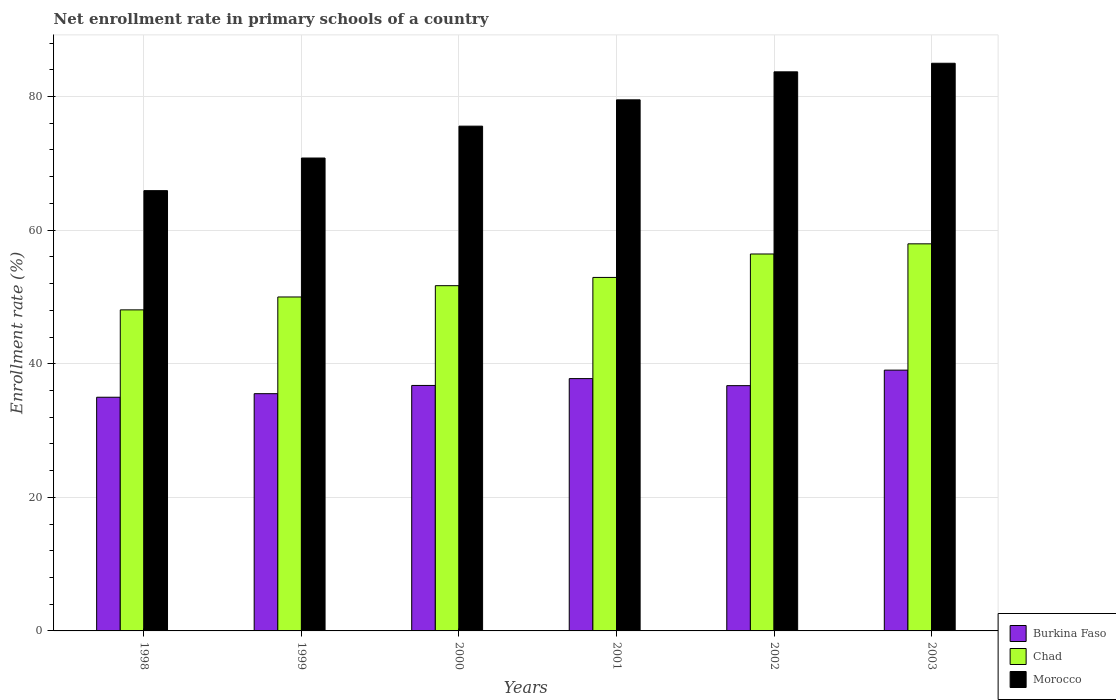Are the number of bars on each tick of the X-axis equal?
Provide a short and direct response. Yes. How many bars are there on the 6th tick from the right?
Offer a terse response. 3. What is the label of the 3rd group of bars from the left?
Provide a short and direct response. 2000. In how many cases, is the number of bars for a given year not equal to the number of legend labels?
Make the answer very short. 0. What is the enrollment rate in primary schools in Burkina Faso in 2000?
Ensure brevity in your answer.  36.75. Across all years, what is the maximum enrollment rate in primary schools in Burkina Faso?
Offer a very short reply. 39.04. Across all years, what is the minimum enrollment rate in primary schools in Chad?
Offer a very short reply. 48.06. In which year was the enrollment rate in primary schools in Chad maximum?
Your answer should be very brief. 2003. In which year was the enrollment rate in primary schools in Morocco minimum?
Offer a terse response. 1998. What is the total enrollment rate in primary schools in Burkina Faso in the graph?
Ensure brevity in your answer.  220.78. What is the difference between the enrollment rate in primary schools in Chad in 1999 and that in 2002?
Your answer should be compact. -6.43. What is the difference between the enrollment rate in primary schools in Burkina Faso in 2000 and the enrollment rate in primary schools in Chad in 2003?
Offer a terse response. -21.2. What is the average enrollment rate in primary schools in Chad per year?
Offer a terse response. 52.84. In the year 1998, what is the difference between the enrollment rate in primary schools in Burkina Faso and enrollment rate in primary schools in Chad?
Your response must be concise. -13.08. In how many years, is the enrollment rate in primary schools in Burkina Faso greater than 84 %?
Offer a terse response. 0. What is the ratio of the enrollment rate in primary schools in Chad in 2001 to that in 2003?
Your answer should be very brief. 0.91. Is the enrollment rate in primary schools in Chad in 1998 less than that in 1999?
Offer a terse response. Yes. Is the difference between the enrollment rate in primary schools in Burkina Faso in 2001 and 2002 greater than the difference between the enrollment rate in primary schools in Chad in 2001 and 2002?
Keep it short and to the point. Yes. What is the difference between the highest and the second highest enrollment rate in primary schools in Burkina Faso?
Keep it short and to the point. 1.27. What is the difference between the highest and the lowest enrollment rate in primary schools in Chad?
Ensure brevity in your answer.  9.88. In how many years, is the enrollment rate in primary schools in Morocco greater than the average enrollment rate in primary schools in Morocco taken over all years?
Offer a very short reply. 3. Is the sum of the enrollment rate in primary schools in Chad in 2001 and 2003 greater than the maximum enrollment rate in primary schools in Morocco across all years?
Your response must be concise. Yes. What does the 3rd bar from the left in 2003 represents?
Offer a terse response. Morocco. What does the 1st bar from the right in 1998 represents?
Keep it short and to the point. Morocco. Is it the case that in every year, the sum of the enrollment rate in primary schools in Burkina Faso and enrollment rate in primary schools in Chad is greater than the enrollment rate in primary schools in Morocco?
Keep it short and to the point. Yes. How many bars are there?
Your answer should be very brief. 18. Are all the bars in the graph horizontal?
Offer a terse response. No. How many years are there in the graph?
Your answer should be very brief. 6. What is the difference between two consecutive major ticks on the Y-axis?
Offer a very short reply. 20. Does the graph contain any zero values?
Offer a very short reply. No. How are the legend labels stacked?
Your answer should be compact. Vertical. What is the title of the graph?
Provide a succinct answer. Net enrollment rate in primary schools of a country. Does "Ecuador" appear as one of the legend labels in the graph?
Your response must be concise. No. What is the label or title of the X-axis?
Your answer should be very brief. Years. What is the label or title of the Y-axis?
Your response must be concise. Enrollment rate (%). What is the Enrollment rate (%) in Burkina Faso in 1998?
Your answer should be very brief. 34.98. What is the Enrollment rate (%) of Chad in 1998?
Provide a succinct answer. 48.06. What is the Enrollment rate (%) in Morocco in 1998?
Provide a short and direct response. 65.91. What is the Enrollment rate (%) of Burkina Faso in 1999?
Ensure brevity in your answer.  35.52. What is the Enrollment rate (%) of Chad in 1999?
Offer a very short reply. 49.99. What is the Enrollment rate (%) in Morocco in 1999?
Your answer should be compact. 70.79. What is the Enrollment rate (%) of Burkina Faso in 2000?
Your response must be concise. 36.75. What is the Enrollment rate (%) of Chad in 2000?
Make the answer very short. 51.68. What is the Enrollment rate (%) in Morocco in 2000?
Your answer should be very brief. 75.57. What is the Enrollment rate (%) in Burkina Faso in 2001?
Provide a short and direct response. 37.77. What is the Enrollment rate (%) in Chad in 2001?
Your response must be concise. 52.92. What is the Enrollment rate (%) in Morocco in 2001?
Your response must be concise. 79.5. What is the Enrollment rate (%) in Burkina Faso in 2002?
Your answer should be compact. 36.72. What is the Enrollment rate (%) of Chad in 2002?
Make the answer very short. 56.43. What is the Enrollment rate (%) of Morocco in 2002?
Ensure brevity in your answer.  83.7. What is the Enrollment rate (%) in Burkina Faso in 2003?
Your answer should be compact. 39.04. What is the Enrollment rate (%) in Chad in 2003?
Provide a short and direct response. 57.95. What is the Enrollment rate (%) in Morocco in 2003?
Provide a short and direct response. 84.98. Across all years, what is the maximum Enrollment rate (%) of Burkina Faso?
Offer a terse response. 39.04. Across all years, what is the maximum Enrollment rate (%) of Chad?
Provide a short and direct response. 57.95. Across all years, what is the maximum Enrollment rate (%) in Morocco?
Make the answer very short. 84.98. Across all years, what is the minimum Enrollment rate (%) of Burkina Faso?
Ensure brevity in your answer.  34.98. Across all years, what is the minimum Enrollment rate (%) in Chad?
Offer a very short reply. 48.06. Across all years, what is the minimum Enrollment rate (%) in Morocco?
Offer a terse response. 65.91. What is the total Enrollment rate (%) of Burkina Faso in the graph?
Offer a very short reply. 220.78. What is the total Enrollment rate (%) of Chad in the graph?
Make the answer very short. 317.03. What is the total Enrollment rate (%) of Morocco in the graph?
Ensure brevity in your answer.  460.45. What is the difference between the Enrollment rate (%) of Burkina Faso in 1998 and that in 1999?
Your answer should be very brief. -0.53. What is the difference between the Enrollment rate (%) in Chad in 1998 and that in 1999?
Keep it short and to the point. -1.93. What is the difference between the Enrollment rate (%) in Morocco in 1998 and that in 1999?
Ensure brevity in your answer.  -4.88. What is the difference between the Enrollment rate (%) in Burkina Faso in 1998 and that in 2000?
Your response must be concise. -1.77. What is the difference between the Enrollment rate (%) in Chad in 1998 and that in 2000?
Make the answer very short. -3.62. What is the difference between the Enrollment rate (%) in Morocco in 1998 and that in 2000?
Provide a short and direct response. -9.66. What is the difference between the Enrollment rate (%) in Burkina Faso in 1998 and that in 2001?
Ensure brevity in your answer.  -2.79. What is the difference between the Enrollment rate (%) in Chad in 1998 and that in 2001?
Give a very brief answer. -4.86. What is the difference between the Enrollment rate (%) of Morocco in 1998 and that in 2001?
Provide a short and direct response. -13.6. What is the difference between the Enrollment rate (%) of Burkina Faso in 1998 and that in 2002?
Ensure brevity in your answer.  -1.74. What is the difference between the Enrollment rate (%) in Chad in 1998 and that in 2002?
Provide a short and direct response. -8.36. What is the difference between the Enrollment rate (%) in Morocco in 1998 and that in 2002?
Offer a very short reply. -17.79. What is the difference between the Enrollment rate (%) of Burkina Faso in 1998 and that in 2003?
Provide a short and direct response. -4.06. What is the difference between the Enrollment rate (%) of Chad in 1998 and that in 2003?
Your answer should be very brief. -9.88. What is the difference between the Enrollment rate (%) of Morocco in 1998 and that in 2003?
Provide a short and direct response. -19.07. What is the difference between the Enrollment rate (%) of Burkina Faso in 1999 and that in 2000?
Give a very brief answer. -1.23. What is the difference between the Enrollment rate (%) in Chad in 1999 and that in 2000?
Your response must be concise. -1.69. What is the difference between the Enrollment rate (%) of Morocco in 1999 and that in 2000?
Provide a succinct answer. -4.77. What is the difference between the Enrollment rate (%) of Burkina Faso in 1999 and that in 2001?
Your answer should be very brief. -2.26. What is the difference between the Enrollment rate (%) in Chad in 1999 and that in 2001?
Your response must be concise. -2.93. What is the difference between the Enrollment rate (%) in Morocco in 1999 and that in 2001?
Your response must be concise. -8.71. What is the difference between the Enrollment rate (%) of Burkina Faso in 1999 and that in 2002?
Provide a short and direct response. -1.2. What is the difference between the Enrollment rate (%) in Chad in 1999 and that in 2002?
Your answer should be compact. -6.43. What is the difference between the Enrollment rate (%) of Morocco in 1999 and that in 2002?
Offer a terse response. -12.9. What is the difference between the Enrollment rate (%) of Burkina Faso in 1999 and that in 2003?
Give a very brief answer. -3.52. What is the difference between the Enrollment rate (%) in Chad in 1999 and that in 2003?
Your answer should be compact. -7.95. What is the difference between the Enrollment rate (%) of Morocco in 1999 and that in 2003?
Make the answer very short. -14.19. What is the difference between the Enrollment rate (%) in Burkina Faso in 2000 and that in 2001?
Keep it short and to the point. -1.02. What is the difference between the Enrollment rate (%) in Chad in 2000 and that in 2001?
Provide a succinct answer. -1.24. What is the difference between the Enrollment rate (%) of Morocco in 2000 and that in 2001?
Provide a succinct answer. -3.94. What is the difference between the Enrollment rate (%) in Burkina Faso in 2000 and that in 2002?
Your answer should be compact. 0.03. What is the difference between the Enrollment rate (%) of Chad in 2000 and that in 2002?
Keep it short and to the point. -4.74. What is the difference between the Enrollment rate (%) of Morocco in 2000 and that in 2002?
Your response must be concise. -8.13. What is the difference between the Enrollment rate (%) in Burkina Faso in 2000 and that in 2003?
Your answer should be compact. -2.29. What is the difference between the Enrollment rate (%) in Chad in 2000 and that in 2003?
Provide a succinct answer. -6.26. What is the difference between the Enrollment rate (%) in Morocco in 2000 and that in 2003?
Keep it short and to the point. -9.41. What is the difference between the Enrollment rate (%) in Burkina Faso in 2001 and that in 2002?
Give a very brief answer. 1.05. What is the difference between the Enrollment rate (%) of Chad in 2001 and that in 2002?
Offer a terse response. -3.51. What is the difference between the Enrollment rate (%) of Morocco in 2001 and that in 2002?
Make the answer very short. -4.19. What is the difference between the Enrollment rate (%) of Burkina Faso in 2001 and that in 2003?
Make the answer very short. -1.27. What is the difference between the Enrollment rate (%) in Chad in 2001 and that in 2003?
Offer a terse response. -5.03. What is the difference between the Enrollment rate (%) of Morocco in 2001 and that in 2003?
Your response must be concise. -5.48. What is the difference between the Enrollment rate (%) of Burkina Faso in 2002 and that in 2003?
Offer a very short reply. -2.32. What is the difference between the Enrollment rate (%) in Chad in 2002 and that in 2003?
Your answer should be compact. -1.52. What is the difference between the Enrollment rate (%) in Morocco in 2002 and that in 2003?
Provide a succinct answer. -1.28. What is the difference between the Enrollment rate (%) of Burkina Faso in 1998 and the Enrollment rate (%) of Chad in 1999?
Your answer should be compact. -15.01. What is the difference between the Enrollment rate (%) in Burkina Faso in 1998 and the Enrollment rate (%) in Morocco in 1999?
Offer a terse response. -35.81. What is the difference between the Enrollment rate (%) in Chad in 1998 and the Enrollment rate (%) in Morocco in 1999?
Provide a succinct answer. -22.73. What is the difference between the Enrollment rate (%) of Burkina Faso in 1998 and the Enrollment rate (%) of Chad in 2000?
Your response must be concise. -16.7. What is the difference between the Enrollment rate (%) in Burkina Faso in 1998 and the Enrollment rate (%) in Morocco in 2000?
Provide a succinct answer. -40.58. What is the difference between the Enrollment rate (%) of Chad in 1998 and the Enrollment rate (%) of Morocco in 2000?
Make the answer very short. -27.5. What is the difference between the Enrollment rate (%) of Burkina Faso in 1998 and the Enrollment rate (%) of Chad in 2001?
Make the answer very short. -17.94. What is the difference between the Enrollment rate (%) of Burkina Faso in 1998 and the Enrollment rate (%) of Morocco in 2001?
Offer a very short reply. -44.52. What is the difference between the Enrollment rate (%) of Chad in 1998 and the Enrollment rate (%) of Morocco in 2001?
Make the answer very short. -31.44. What is the difference between the Enrollment rate (%) in Burkina Faso in 1998 and the Enrollment rate (%) in Chad in 2002?
Offer a terse response. -21.44. What is the difference between the Enrollment rate (%) of Burkina Faso in 1998 and the Enrollment rate (%) of Morocco in 2002?
Ensure brevity in your answer.  -48.72. What is the difference between the Enrollment rate (%) in Chad in 1998 and the Enrollment rate (%) in Morocco in 2002?
Make the answer very short. -35.63. What is the difference between the Enrollment rate (%) in Burkina Faso in 1998 and the Enrollment rate (%) in Chad in 2003?
Your answer should be very brief. -22.97. What is the difference between the Enrollment rate (%) in Burkina Faso in 1998 and the Enrollment rate (%) in Morocco in 2003?
Provide a short and direct response. -50. What is the difference between the Enrollment rate (%) in Chad in 1998 and the Enrollment rate (%) in Morocco in 2003?
Your answer should be very brief. -36.92. What is the difference between the Enrollment rate (%) of Burkina Faso in 1999 and the Enrollment rate (%) of Chad in 2000?
Keep it short and to the point. -16.17. What is the difference between the Enrollment rate (%) in Burkina Faso in 1999 and the Enrollment rate (%) in Morocco in 2000?
Keep it short and to the point. -40.05. What is the difference between the Enrollment rate (%) of Chad in 1999 and the Enrollment rate (%) of Morocco in 2000?
Your answer should be compact. -25.57. What is the difference between the Enrollment rate (%) of Burkina Faso in 1999 and the Enrollment rate (%) of Chad in 2001?
Give a very brief answer. -17.4. What is the difference between the Enrollment rate (%) in Burkina Faso in 1999 and the Enrollment rate (%) in Morocco in 2001?
Your answer should be very brief. -43.99. What is the difference between the Enrollment rate (%) of Chad in 1999 and the Enrollment rate (%) of Morocco in 2001?
Your answer should be very brief. -29.51. What is the difference between the Enrollment rate (%) of Burkina Faso in 1999 and the Enrollment rate (%) of Chad in 2002?
Keep it short and to the point. -20.91. What is the difference between the Enrollment rate (%) of Burkina Faso in 1999 and the Enrollment rate (%) of Morocco in 2002?
Your answer should be compact. -48.18. What is the difference between the Enrollment rate (%) in Chad in 1999 and the Enrollment rate (%) in Morocco in 2002?
Make the answer very short. -33.7. What is the difference between the Enrollment rate (%) of Burkina Faso in 1999 and the Enrollment rate (%) of Chad in 2003?
Keep it short and to the point. -22.43. What is the difference between the Enrollment rate (%) of Burkina Faso in 1999 and the Enrollment rate (%) of Morocco in 2003?
Your answer should be very brief. -49.46. What is the difference between the Enrollment rate (%) in Chad in 1999 and the Enrollment rate (%) in Morocco in 2003?
Offer a very short reply. -34.99. What is the difference between the Enrollment rate (%) in Burkina Faso in 2000 and the Enrollment rate (%) in Chad in 2001?
Your answer should be very brief. -16.17. What is the difference between the Enrollment rate (%) in Burkina Faso in 2000 and the Enrollment rate (%) in Morocco in 2001?
Your response must be concise. -42.76. What is the difference between the Enrollment rate (%) in Chad in 2000 and the Enrollment rate (%) in Morocco in 2001?
Your answer should be very brief. -27.82. What is the difference between the Enrollment rate (%) of Burkina Faso in 2000 and the Enrollment rate (%) of Chad in 2002?
Give a very brief answer. -19.68. What is the difference between the Enrollment rate (%) in Burkina Faso in 2000 and the Enrollment rate (%) in Morocco in 2002?
Your response must be concise. -46.95. What is the difference between the Enrollment rate (%) in Chad in 2000 and the Enrollment rate (%) in Morocco in 2002?
Provide a short and direct response. -32.01. What is the difference between the Enrollment rate (%) in Burkina Faso in 2000 and the Enrollment rate (%) in Chad in 2003?
Make the answer very short. -21.2. What is the difference between the Enrollment rate (%) in Burkina Faso in 2000 and the Enrollment rate (%) in Morocco in 2003?
Your answer should be very brief. -48.23. What is the difference between the Enrollment rate (%) of Chad in 2000 and the Enrollment rate (%) of Morocco in 2003?
Your answer should be very brief. -33.3. What is the difference between the Enrollment rate (%) in Burkina Faso in 2001 and the Enrollment rate (%) in Chad in 2002?
Give a very brief answer. -18.65. What is the difference between the Enrollment rate (%) in Burkina Faso in 2001 and the Enrollment rate (%) in Morocco in 2002?
Offer a very short reply. -45.93. What is the difference between the Enrollment rate (%) in Chad in 2001 and the Enrollment rate (%) in Morocco in 2002?
Your answer should be very brief. -30.78. What is the difference between the Enrollment rate (%) in Burkina Faso in 2001 and the Enrollment rate (%) in Chad in 2003?
Make the answer very short. -20.18. What is the difference between the Enrollment rate (%) of Burkina Faso in 2001 and the Enrollment rate (%) of Morocco in 2003?
Ensure brevity in your answer.  -47.21. What is the difference between the Enrollment rate (%) of Chad in 2001 and the Enrollment rate (%) of Morocco in 2003?
Your response must be concise. -32.06. What is the difference between the Enrollment rate (%) in Burkina Faso in 2002 and the Enrollment rate (%) in Chad in 2003?
Give a very brief answer. -21.23. What is the difference between the Enrollment rate (%) of Burkina Faso in 2002 and the Enrollment rate (%) of Morocco in 2003?
Make the answer very short. -48.26. What is the difference between the Enrollment rate (%) in Chad in 2002 and the Enrollment rate (%) in Morocco in 2003?
Your response must be concise. -28.55. What is the average Enrollment rate (%) of Burkina Faso per year?
Offer a terse response. 36.8. What is the average Enrollment rate (%) of Chad per year?
Offer a terse response. 52.84. What is the average Enrollment rate (%) in Morocco per year?
Your response must be concise. 76.74. In the year 1998, what is the difference between the Enrollment rate (%) of Burkina Faso and Enrollment rate (%) of Chad?
Your answer should be compact. -13.08. In the year 1998, what is the difference between the Enrollment rate (%) in Burkina Faso and Enrollment rate (%) in Morocco?
Your response must be concise. -30.93. In the year 1998, what is the difference between the Enrollment rate (%) in Chad and Enrollment rate (%) in Morocco?
Give a very brief answer. -17.85. In the year 1999, what is the difference between the Enrollment rate (%) in Burkina Faso and Enrollment rate (%) in Chad?
Offer a terse response. -14.48. In the year 1999, what is the difference between the Enrollment rate (%) in Burkina Faso and Enrollment rate (%) in Morocco?
Offer a terse response. -35.28. In the year 1999, what is the difference between the Enrollment rate (%) in Chad and Enrollment rate (%) in Morocco?
Your answer should be compact. -20.8. In the year 2000, what is the difference between the Enrollment rate (%) in Burkina Faso and Enrollment rate (%) in Chad?
Your response must be concise. -14.94. In the year 2000, what is the difference between the Enrollment rate (%) of Burkina Faso and Enrollment rate (%) of Morocco?
Your response must be concise. -38.82. In the year 2000, what is the difference between the Enrollment rate (%) of Chad and Enrollment rate (%) of Morocco?
Give a very brief answer. -23.88. In the year 2001, what is the difference between the Enrollment rate (%) of Burkina Faso and Enrollment rate (%) of Chad?
Provide a short and direct response. -15.15. In the year 2001, what is the difference between the Enrollment rate (%) of Burkina Faso and Enrollment rate (%) of Morocco?
Ensure brevity in your answer.  -41.73. In the year 2001, what is the difference between the Enrollment rate (%) of Chad and Enrollment rate (%) of Morocco?
Your answer should be very brief. -26.59. In the year 2002, what is the difference between the Enrollment rate (%) in Burkina Faso and Enrollment rate (%) in Chad?
Your answer should be compact. -19.71. In the year 2002, what is the difference between the Enrollment rate (%) of Burkina Faso and Enrollment rate (%) of Morocco?
Keep it short and to the point. -46.98. In the year 2002, what is the difference between the Enrollment rate (%) in Chad and Enrollment rate (%) in Morocco?
Make the answer very short. -27.27. In the year 2003, what is the difference between the Enrollment rate (%) in Burkina Faso and Enrollment rate (%) in Chad?
Make the answer very short. -18.91. In the year 2003, what is the difference between the Enrollment rate (%) in Burkina Faso and Enrollment rate (%) in Morocco?
Your response must be concise. -45.94. In the year 2003, what is the difference between the Enrollment rate (%) of Chad and Enrollment rate (%) of Morocco?
Your response must be concise. -27.03. What is the ratio of the Enrollment rate (%) in Burkina Faso in 1998 to that in 1999?
Keep it short and to the point. 0.98. What is the ratio of the Enrollment rate (%) in Chad in 1998 to that in 1999?
Your answer should be very brief. 0.96. What is the ratio of the Enrollment rate (%) in Burkina Faso in 1998 to that in 2000?
Your answer should be compact. 0.95. What is the ratio of the Enrollment rate (%) of Chad in 1998 to that in 2000?
Offer a very short reply. 0.93. What is the ratio of the Enrollment rate (%) in Morocco in 1998 to that in 2000?
Keep it short and to the point. 0.87. What is the ratio of the Enrollment rate (%) in Burkina Faso in 1998 to that in 2001?
Keep it short and to the point. 0.93. What is the ratio of the Enrollment rate (%) of Chad in 1998 to that in 2001?
Ensure brevity in your answer.  0.91. What is the ratio of the Enrollment rate (%) in Morocco in 1998 to that in 2001?
Provide a succinct answer. 0.83. What is the ratio of the Enrollment rate (%) in Burkina Faso in 1998 to that in 2002?
Provide a succinct answer. 0.95. What is the ratio of the Enrollment rate (%) in Chad in 1998 to that in 2002?
Your response must be concise. 0.85. What is the ratio of the Enrollment rate (%) of Morocco in 1998 to that in 2002?
Make the answer very short. 0.79. What is the ratio of the Enrollment rate (%) in Burkina Faso in 1998 to that in 2003?
Keep it short and to the point. 0.9. What is the ratio of the Enrollment rate (%) in Chad in 1998 to that in 2003?
Make the answer very short. 0.83. What is the ratio of the Enrollment rate (%) of Morocco in 1998 to that in 2003?
Ensure brevity in your answer.  0.78. What is the ratio of the Enrollment rate (%) of Burkina Faso in 1999 to that in 2000?
Offer a terse response. 0.97. What is the ratio of the Enrollment rate (%) of Chad in 1999 to that in 2000?
Your answer should be very brief. 0.97. What is the ratio of the Enrollment rate (%) in Morocco in 1999 to that in 2000?
Your answer should be very brief. 0.94. What is the ratio of the Enrollment rate (%) in Burkina Faso in 1999 to that in 2001?
Offer a very short reply. 0.94. What is the ratio of the Enrollment rate (%) in Chad in 1999 to that in 2001?
Give a very brief answer. 0.94. What is the ratio of the Enrollment rate (%) of Morocco in 1999 to that in 2001?
Make the answer very short. 0.89. What is the ratio of the Enrollment rate (%) in Burkina Faso in 1999 to that in 2002?
Provide a short and direct response. 0.97. What is the ratio of the Enrollment rate (%) of Chad in 1999 to that in 2002?
Your response must be concise. 0.89. What is the ratio of the Enrollment rate (%) in Morocco in 1999 to that in 2002?
Your answer should be compact. 0.85. What is the ratio of the Enrollment rate (%) in Burkina Faso in 1999 to that in 2003?
Keep it short and to the point. 0.91. What is the ratio of the Enrollment rate (%) in Chad in 1999 to that in 2003?
Offer a terse response. 0.86. What is the ratio of the Enrollment rate (%) in Morocco in 1999 to that in 2003?
Your response must be concise. 0.83. What is the ratio of the Enrollment rate (%) in Burkina Faso in 2000 to that in 2001?
Keep it short and to the point. 0.97. What is the ratio of the Enrollment rate (%) of Chad in 2000 to that in 2001?
Ensure brevity in your answer.  0.98. What is the ratio of the Enrollment rate (%) in Morocco in 2000 to that in 2001?
Your answer should be very brief. 0.95. What is the ratio of the Enrollment rate (%) in Chad in 2000 to that in 2002?
Make the answer very short. 0.92. What is the ratio of the Enrollment rate (%) of Morocco in 2000 to that in 2002?
Keep it short and to the point. 0.9. What is the ratio of the Enrollment rate (%) of Burkina Faso in 2000 to that in 2003?
Offer a very short reply. 0.94. What is the ratio of the Enrollment rate (%) of Chad in 2000 to that in 2003?
Make the answer very short. 0.89. What is the ratio of the Enrollment rate (%) in Morocco in 2000 to that in 2003?
Provide a succinct answer. 0.89. What is the ratio of the Enrollment rate (%) of Burkina Faso in 2001 to that in 2002?
Give a very brief answer. 1.03. What is the ratio of the Enrollment rate (%) of Chad in 2001 to that in 2002?
Provide a short and direct response. 0.94. What is the ratio of the Enrollment rate (%) of Morocco in 2001 to that in 2002?
Give a very brief answer. 0.95. What is the ratio of the Enrollment rate (%) in Burkina Faso in 2001 to that in 2003?
Provide a succinct answer. 0.97. What is the ratio of the Enrollment rate (%) of Chad in 2001 to that in 2003?
Offer a terse response. 0.91. What is the ratio of the Enrollment rate (%) of Morocco in 2001 to that in 2003?
Provide a short and direct response. 0.94. What is the ratio of the Enrollment rate (%) in Burkina Faso in 2002 to that in 2003?
Make the answer very short. 0.94. What is the ratio of the Enrollment rate (%) in Chad in 2002 to that in 2003?
Make the answer very short. 0.97. What is the ratio of the Enrollment rate (%) in Morocco in 2002 to that in 2003?
Offer a terse response. 0.98. What is the difference between the highest and the second highest Enrollment rate (%) of Burkina Faso?
Make the answer very short. 1.27. What is the difference between the highest and the second highest Enrollment rate (%) of Chad?
Give a very brief answer. 1.52. What is the difference between the highest and the second highest Enrollment rate (%) of Morocco?
Provide a succinct answer. 1.28. What is the difference between the highest and the lowest Enrollment rate (%) in Burkina Faso?
Your answer should be very brief. 4.06. What is the difference between the highest and the lowest Enrollment rate (%) in Chad?
Ensure brevity in your answer.  9.88. What is the difference between the highest and the lowest Enrollment rate (%) in Morocco?
Offer a terse response. 19.07. 